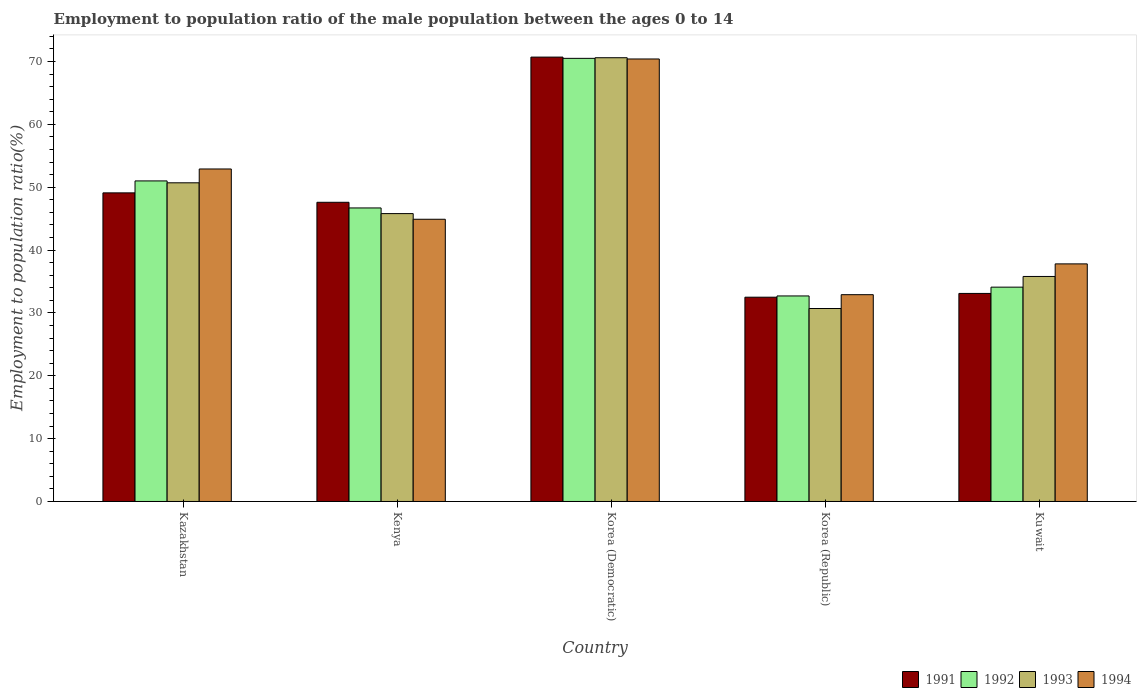Are the number of bars per tick equal to the number of legend labels?
Provide a succinct answer. Yes. How many bars are there on the 4th tick from the left?
Offer a terse response. 4. What is the label of the 5th group of bars from the left?
Provide a succinct answer. Kuwait. In how many cases, is the number of bars for a given country not equal to the number of legend labels?
Make the answer very short. 0. What is the employment to population ratio in 1992 in Kuwait?
Your answer should be compact. 34.1. Across all countries, what is the maximum employment to population ratio in 1994?
Offer a terse response. 70.4. Across all countries, what is the minimum employment to population ratio in 1994?
Your response must be concise. 32.9. In which country was the employment to population ratio in 1993 maximum?
Give a very brief answer. Korea (Democratic). In which country was the employment to population ratio in 1993 minimum?
Offer a very short reply. Korea (Republic). What is the total employment to population ratio in 1992 in the graph?
Your answer should be very brief. 235. What is the difference between the employment to population ratio in 1993 in Korea (Republic) and that in Kuwait?
Offer a very short reply. -5.1. What is the difference between the employment to population ratio in 1994 in Korea (Democratic) and the employment to population ratio in 1992 in Kenya?
Your answer should be very brief. 23.7. What is the average employment to population ratio in 1993 per country?
Keep it short and to the point. 46.72. What is the difference between the employment to population ratio of/in 1992 and employment to population ratio of/in 1993 in Kenya?
Give a very brief answer. 0.9. What is the ratio of the employment to population ratio in 1994 in Kenya to that in Korea (Republic)?
Your response must be concise. 1.36. What is the difference between the highest and the second highest employment to population ratio in 1994?
Offer a very short reply. -17.5. What is the difference between the highest and the lowest employment to population ratio in 1993?
Keep it short and to the point. 39.9. What does the 2nd bar from the left in Korea (Republic) represents?
Offer a very short reply. 1992. What does the 3rd bar from the right in Kenya represents?
Offer a terse response. 1992. Does the graph contain any zero values?
Offer a very short reply. No. How many legend labels are there?
Make the answer very short. 4. How are the legend labels stacked?
Ensure brevity in your answer.  Horizontal. What is the title of the graph?
Give a very brief answer. Employment to population ratio of the male population between the ages 0 to 14. Does "2003" appear as one of the legend labels in the graph?
Make the answer very short. No. What is the label or title of the X-axis?
Keep it short and to the point. Country. What is the label or title of the Y-axis?
Your answer should be compact. Employment to population ratio(%). What is the Employment to population ratio(%) in 1991 in Kazakhstan?
Keep it short and to the point. 49.1. What is the Employment to population ratio(%) in 1993 in Kazakhstan?
Make the answer very short. 50.7. What is the Employment to population ratio(%) in 1994 in Kazakhstan?
Your answer should be compact. 52.9. What is the Employment to population ratio(%) in 1991 in Kenya?
Your response must be concise. 47.6. What is the Employment to population ratio(%) of 1992 in Kenya?
Ensure brevity in your answer.  46.7. What is the Employment to population ratio(%) in 1993 in Kenya?
Keep it short and to the point. 45.8. What is the Employment to population ratio(%) in 1994 in Kenya?
Your answer should be very brief. 44.9. What is the Employment to population ratio(%) of 1991 in Korea (Democratic)?
Make the answer very short. 70.7. What is the Employment to population ratio(%) in 1992 in Korea (Democratic)?
Offer a terse response. 70.5. What is the Employment to population ratio(%) in 1993 in Korea (Democratic)?
Your response must be concise. 70.6. What is the Employment to population ratio(%) in 1994 in Korea (Democratic)?
Make the answer very short. 70.4. What is the Employment to population ratio(%) of 1991 in Korea (Republic)?
Your answer should be compact. 32.5. What is the Employment to population ratio(%) in 1992 in Korea (Republic)?
Your response must be concise. 32.7. What is the Employment to population ratio(%) in 1993 in Korea (Republic)?
Your answer should be very brief. 30.7. What is the Employment to population ratio(%) of 1994 in Korea (Republic)?
Your answer should be very brief. 32.9. What is the Employment to population ratio(%) in 1991 in Kuwait?
Make the answer very short. 33.1. What is the Employment to population ratio(%) of 1992 in Kuwait?
Your answer should be compact. 34.1. What is the Employment to population ratio(%) in 1993 in Kuwait?
Offer a terse response. 35.8. What is the Employment to population ratio(%) of 1994 in Kuwait?
Provide a short and direct response. 37.8. Across all countries, what is the maximum Employment to population ratio(%) of 1991?
Offer a very short reply. 70.7. Across all countries, what is the maximum Employment to population ratio(%) in 1992?
Keep it short and to the point. 70.5. Across all countries, what is the maximum Employment to population ratio(%) in 1993?
Ensure brevity in your answer.  70.6. Across all countries, what is the maximum Employment to population ratio(%) in 1994?
Provide a short and direct response. 70.4. Across all countries, what is the minimum Employment to population ratio(%) of 1991?
Your answer should be very brief. 32.5. Across all countries, what is the minimum Employment to population ratio(%) in 1992?
Your answer should be very brief. 32.7. Across all countries, what is the minimum Employment to population ratio(%) of 1993?
Your response must be concise. 30.7. Across all countries, what is the minimum Employment to population ratio(%) of 1994?
Offer a terse response. 32.9. What is the total Employment to population ratio(%) of 1991 in the graph?
Provide a short and direct response. 233. What is the total Employment to population ratio(%) of 1992 in the graph?
Provide a short and direct response. 235. What is the total Employment to population ratio(%) in 1993 in the graph?
Offer a very short reply. 233.6. What is the total Employment to population ratio(%) of 1994 in the graph?
Your answer should be very brief. 238.9. What is the difference between the Employment to population ratio(%) in 1991 in Kazakhstan and that in Korea (Democratic)?
Provide a succinct answer. -21.6. What is the difference between the Employment to population ratio(%) of 1992 in Kazakhstan and that in Korea (Democratic)?
Your answer should be compact. -19.5. What is the difference between the Employment to population ratio(%) of 1993 in Kazakhstan and that in Korea (Democratic)?
Offer a terse response. -19.9. What is the difference between the Employment to population ratio(%) in 1994 in Kazakhstan and that in Korea (Democratic)?
Provide a short and direct response. -17.5. What is the difference between the Employment to population ratio(%) in 1991 in Kazakhstan and that in Korea (Republic)?
Keep it short and to the point. 16.6. What is the difference between the Employment to population ratio(%) in 1991 in Kazakhstan and that in Kuwait?
Provide a short and direct response. 16. What is the difference between the Employment to population ratio(%) of 1991 in Kenya and that in Korea (Democratic)?
Offer a very short reply. -23.1. What is the difference between the Employment to population ratio(%) in 1992 in Kenya and that in Korea (Democratic)?
Give a very brief answer. -23.8. What is the difference between the Employment to population ratio(%) in 1993 in Kenya and that in Korea (Democratic)?
Provide a short and direct response. -24.8. What is the difference between the Employment to population ratio(%) of 1994 in Kenya and that in Korea (Democratic)?
Ensure brevity in your answer.  -25.5. What is the difference between the Employment to population ratio(%) in 1991 in Kenya and that in Korea (Republic)?
Give a very brief answer. 15.1. What is the difference between the Employment to population ratio(%) of 1991 in Kenya and that in Kuwait?
Make the answer very short. 14.5. What is the difference between the Employment to population ratio(%) of 1993 in Kenya and that in Kuwait?
Keep it short and to the point. 10. What is the difference between the Employment to population ratio(%) in 1994 in Kenya and that in Kuwait?
Your response must be concise. 7.1. What is the difference between the Employment to population ratio(%) of 1991 in Korea (Democratic) and that in Korea (Republic)?
Make the answer very short. 38.2. What is the difference between the Employment to population ratio(%) in 1992 in Korea (Democratic) and that in Korea (Republic)?
Offer a terse response. 37.8. What is the difference between the Employment to population ratio(%) of 1993 in Korea (Democratic) and that in Korea (Republic)?
Your answer should be compact. 39.9. What is the difference between the Employment to population ratio(%) of 1994 in Korea (Democratic) and that in Korea (Republic)?
Ensure brevity in your answer.  37.5. What is the difference between the Employment to population ratio(%) of 1991 in Korea (Democratic) and that in Kuwait?
Give a very brief answer. 37.6. What is the difference between the Employment to population ratio(%) in 1992 in Korea (Democratic) and that in Kuwait?
Provide a short and direct response. 36.4. What is the difference between the Employment to population ratio(%) in 1993 in Korea (Democratic) and that in Kuwait?
Provide a short and direct response. 34.8. What is the difference between the Employment to population ratio(%) of 1994 in Korea (Democratic) and that in Kuwait?
Your answer should be compact. 32.6. What is the difference between the Employment to population ratio(%) in 1991 in Korea (Republic) and that in Kuwait?
Ensure brevity in your answer.  -0.6. What is the difference between the Employment to population ratio(%) in 1992 in Korea (Republic) and that in Kuwait?
Offer a very short reply. -1.4. What is the difference between the Employment to population ratio(%) in 1993 in Korea (Republic) and that in Kuwait?
Offer a very short reply. -5.1. What is the difference between the Employment to population ratio(%) of 1994 in Korea (Republic) and that in Kuwait?
Offer a very short reply. -4.9. What is the difference between the Employment to population ratio(%) in 1992 in Kazakhstan and the Employment to population ratio(%) in 1994 in Kenya?
Your answer should be compact. 6.1. What is the difference between the Employment to population ratio(%) in 1991 in Kazakhstan and the Employment to population ratio(%) in 1992 in Korea (Democratic)?
Give a very brief answer. -21.4. What is the difference between the Employment to population ratio(%) in 1991 in Kazakhstan and the Employment to population ratio(%) in 1993 in Korea (Democratic)?
Keep it short and to the point. -21.5. What is the difference between the Employment to population ratio(%) in 1991 in Kazakhstan and the Employment to population ratio(%) in 1994 in Korea (Democratic)?
Give a very brief answer. -21.3. What is the difference between the Employment to population ratio(%) of 1992 in Kazakhstan and the Employment to population ratio(%) of 1993 in Korea (Democratic)?
Make the answer very short. -19.6. What is the difference between the Employment to population ratio(%) in 1992 in Kazakhstan and the Employment to population ratio(%) in 1994 in Korea (Democratic)?
Provide a succinct answer. -19.4. What is the difference between the Employment to population ratio(%) of 1993 in Kazakhstan and the Employment to population ratio(%) of 1994 in Korea (Democratic)?
Offer a very short reply. -19.7. What is the difference between the Employment to population ratio(%) of 1991 in Kazakhstan and the Employment to population ratio(%) of 1993 in Korea (Republic)?
Give a very brief answer. 18.4. What is the difference between the Employment to population ratio(%) of 1992 in Kazakhstan and the Employment to population ratio(%) of 1993 in Korea (Republic)?
Offer a very short reply. 20.3. What is the difference between the Employment to population ratio(%) of 1992 in Kazakhstan and the Employment to population ratio(%) of 1993 in Kuwait?
Make the answer very short. 15.2. What is the difference between the Employment to population ratio(%) in 1993 in Kazakhstan and the Employment to population ratio(%) in 1994 in Kuwait?
Ensure brevity in your answer.  12.9. What is the difference between the Employment to population ratio(%) of 1991 in Kenya and the Employment to population ratio(%) of 1992 in Korea (Democratic)?
Offer a terse response. -22.9. What is the difference between the Employment to population ratio(%) in 1991 in Kenya and the Employment to population ratio(%) in 1994 in Korea (Democratic)?
Provide a short and direct response. -22.8. What is the difference between the Employment to population ratio(%) of 1992 in Kenya and the Employment to population ratio(%) of 1993 in Korea (Democratic)?
Provide a short and direct response. -23.9. What is the difference between the Employment to population ratio(%) of 1992 in Kenya and the Employment to population ratio(%) of 1994 in Korea (Democratic)?
Provide a succinct answer. -23.7. What is the difference between the Employment to population ratio(%) of 1993 in Kenya and the Employment to population ratio(%) of 1994 in Korea (Democratic)?
Offer a very short reply. -24.6. What is the difference between the Employment to population ratio(%) in 1991 in Kenya and the Employment to population ratio(%) in 1992 in Korea (Republic)?
Offer a very short reply. 14.9. What is the difference between the Employment to population ratio(%) of 1991 in Kenya and the Employment to population ratio(%) of 1993 in Korea (Republic)?
Your answer should be compact. 16.9. What is the difference between the Employment to population ratio(%) of 1991 in Kenya and the Employment to population ratio(%) of 1994 in Korea (Republic)?
Your answer should be compact. 14.7. What is the difference between the Employment to population ratio(%) of 1992 in Kenya and the Employment to population ratio(%) of 1993 in Korea (Republic)?
Make the answer very short. 16. What is the difference between the Employment to population ratio(%) in 1993 in Kenya and the Employment to population ratio(%) in 1994 in Korea (Republic)?
Offer a very short reply. 12.9. What is the difference between the Employment to population ratio(%) of 1991 in Kenya and the Employment to population ratio(%) of 1994 in Kuwait?
Ensure brevity in your answer.  9.8. What is the difference between the Employment to population ratio(%) of 1992 in Kenya and the Employment to population ratio(%) of 1993 in Kuwait?
Offer a terse response. 10.9. What is the difference between the Employment to population ratio(%) of 1992 in Kenya and the Employment to population ratio(%) of 1994 in Kuwait?
Give a very brief answer. 8.9. What is the difference between the Employment to population ratio(%) in 1993 in Kenya and the Employment to population ratio(%) in 1994 in Kuwait?
Your answer should be very brief. 8. What is the difference between the Employment to population ratio(%) in 1991 in Korea (Democratic) and the Employment to population ratio(%) in 1992 in Korea (Republic)?
Make the answer very short. 38. What is the difference between the Employment to population ratio(%) of 1991 in Korea (Democratic) and the Employment to population ratio(%) of 1994 in Korea (Republic)?
Provide a succinct answer. 37.8. What is the difference between the Employment to population ratio(%) of 1992 in Korea (Democratic) and the Employment to population ratio(%) of 1993 in Korea (Republic)?
Provide a short and direct response. 39.8. What is the difference between the Employment to population ratio(%) of 1992 in Korea (Democratic) and the Employment to population ratio(%) of 1994 in Korea (Republic)?
Provide a short and direct response. 37.6. What is the difference between the Employment to population ratio(%) of 1993 in Korea (Democratic) and the Employment to population ratio(%) of 1994 in Korea (Republic)?
Your answer should be compact. 37.7. What is the difference between the Employment to population ratio(%) in 1991 in Korea (Democratic) and the Employment to population ratio(%) in 1992 in Kuwait?
Provide a short and direct response. 36.6. What is the difference between the Employment to population ratio(%) of 1991 in Korea (Democratic) and the Employment to population ratio(%) of 1993 in Kuwait?
Your answer should be compact. 34.9. What is the difference between the Employment to population ratio(%) in 1991 in Korea (Democratic) and the Employment to population ratio(%) in 1994 in Kuwait?
Ensure brevity in your answer.  32.9. What is the difference between the Employment to population ratio(%) in 1992 in Korea (Democratic) and the Employment to population ratio(%) in 1993 in Kuwait?
Offer a terse response. 34.7. What is the difference between the Employment to population ratio(%) in 1992 in Korea (Democratic) and the Employment to population ratio(%) in 1994 in Kuwait?
Your answer should be very brief. 32.7. What is the difference between the Employment to population ratio(%) of 1993 in Korea (Democratic) and the Employment to population ratio(%) of 1994 in Kuwait?
Make the answer very short. 32.8. What is the difference between the Employment to population ratio(%) of 1991 in Korea (Republic) and the Employment to population ratio(%) of 1994 in Kuwait?
Your answer should be very brief. -5.3. What is the difference between the Employment to population ratio(%) of 1992 in Korea (Republic) and the Employment to population ratio(%) of 1993 in Kuwait?
Your response must be concise. -3.1. What is the difference between the Employment to population ratio(%) of 1993 in Korea (Republic) and the Employment to population ratio(%) of 1994 in Kuwait?
Provide a short and direct response. -7.1. What is the average Employment to population ratio(%) of 1991 per country?
Offer a terse response. 46.6. What is the average Employment to population ratio(%) of 1992 per country?
Provide a succinct answer. 47. What is the average Employment to population ratio(%) of 1993 per country?
Provide a short and direct response. 46.72. What is the average Employment to population ratio(%) of 1994 per country?
Ensure brevity in your answer.  47.78. What is the difference between the Employment to population ratio(%) of 1991 and Employment to population ratio(%) of 1992 in Kazakhstan?
Keep it short and to the point. -1.9. What is the difference between the Employment to population ratio(%) in 1991 and Employment to population ratio(%) in 1993 in Kazakhstan?
Offer a very short reply. -1.6. What is the difference between the Employment to population ratio(%) in 1993 and Employment to population ratio(%) in 1994 in Kazakhstan?
Provide a succinct answer. -2.2. What is the difference between the Employment to population ratio(%) in 1991 and Employment to population ratio(%) in 1992 in Kenya?
Give a very brief answer. 0.9. What is the difference between the Employment to population ratio(%) of 1991 and Employment to population ratio(%) of 1994 in Kenya?
Offer a very short reply. 2.7. What is the difference between the Employment to population ratio(%) of 1992 and Employment to population ratio(%) of 1993 in Kenya?
Offer a very short reply. 0.9. What is the difference between the Employment to population ratio(%) of 1992 and Employment to population ratio(%) of 1994 in Kenya?
Offer a very short reply. 1.8. What is the difference between the Employment to population ratio(%) of 1993 and Employment to population ratio(%) of 1994 in Kenya?
Your answer should be compact. 0.9. What is the difference between the Employment to population ratio(%) of 1991 and Employment to population ratio(%) of 1993 in Korea (Democratic)?
Your response must be concise. 0.1. What is the difference between the Employment to population ratio(%) in 1991 and Employment to population ratio(%) in 1994 in Korea (Democratic)?
Offer a terse response. 0.3. What is the difference between the Employment to population ratio(%) in 1992 and Employment to population ratio(%) in 1993 in Korea (Democratic)?
Your response must be concise. -0.1. What is the difference between the Employment to population ratio(%) of 1992 and Employment to population ratio(%) of 1994 in Korea (Democratic)?
Your response must be concise. 0.1. What is the difference between the Employment to population ratio(%) in 1993 and Employment to population ratio(%) in 1994 in Korea (Democratic)?
Provide a short and direct response. 0.2. What is the difference between the Employment to population ratio(%) of 1991 and Employment to population ratio(%) of 1992 in Korea (Republic)?
Provide a short and direct response. -0.2. What is the difference between the Employment to population ratio(%) of 1991 and Employment to population ratio(%) of 1993 in Korea (Republic)?
Your answer should be compact. 1.8. What is the difference between the Employment to population ratio(%) of 1993 and Employment to population ratio(%) of 1994 in Korea (Republic)?
Offer a very short reply. -2.2. What is the difference between the Employment to population ratio(%) in 1991 and Employment to population ratio(%) in 1992 in Kuwait?
Your response must be concise. -1. What is the difference between the Employment to population ratio(%) of 1992 and Employment to population ratio(%) of 1993 in Kuwait?
Offer a terse response. -1.7. What is the ratio of the Employment to population ratio(%) in 1991 in Kazakhstan to that in Kenya?
Provide a short and direct response. 1.03. What is the ratio of the Employment to population ratio(%) of 1992 in Kazakhstan to that in Kenya?
Provide a succinct answer. 1.09. What is the ratio of the Employment to population ratio(%) in 1993 in Kazakhstan to that in Kenya?
Offer a very short reply. 1.11. What is the ratio of the Employment to population ratio(%) of 1994 in Kazakhstan to that in Kenya?
Offer a terse response. 1.18. What is the ratio of the Employment to population ratio(%) of 1991 in Kazakhstan to that in Korea (Democratic)?
Make the answer very short. 0.69. What is the ratio of the Employment to population ratio(%) of 1992 in Kazakhstan to that in Korea (Democratic)?
Ensure brevity in your answer.  0.72. What is the ratio of the Employment to population ratio(%) in 1993 in Kazakhstan to that in Korea (Democratic)?
Offer a very short reply. 0.72. What is the ratio of the Employment to population ratio(%) in 1994 in Kazakhstan to that in Korea (Democratic)?
Keep it short and to the point. 0.75. What is the ratio of the Employment to population ratio(%) in 1991 in Kazakhstan to that in Korea (Republic)?
Your response must be concise. 1.51. What is the ratio of the Employment to population ratio(%) of 1992 in Kazakhstan to that in Korea (Republic)?
Your answer should be very brief. 1.56. What is the ratio of the Employment to population ratio(%) in 1993 in Kazakhstan to that in Korea (Republic)?
Offer a very short reply. 1.65. What is the ratio of the Employment to population ratio(%) in 1994 in Kazakhstan to that in Korea (Republic)?
Your answer should be compact. 1.61. What is the ratio of the Employment to population ratio(%) of 1991 in Kazakhstan to that in Kuwait?
Offer a very short reply. 1.48. What is the ratio of the Employment to population ratio(%) of 1992 in Kazakhstan to that in Kuwait?
Your answer should be compact. 1.5. What is the ratio of the Employment to population ratio(%) in 1993 in Kazakhstan to that in Kuwait?
Give a very brief answer. 1.42. What is the ratio of the Employment to population ratio(%) in 1994 in Kazakhstan to that in Kuwait?
Keep it short and to the point. 1.4. What is the ratio of the Employment to population ratio(%) of 1991 in Kenya to that in Korea (Democratic)?
Offer a terse response. 0.67. What is the ratio of the Employment to population ratio(%) in 1992 in Kenya to that in Korea (Democratic)?
Your answer should be compact. 0.66. What is the ratio of the Employment to population ratio(%) in 1993 in Kenya to that in Korea (Democratic)?
Your answer should be compact. 0.65. What is the ratio of the Employment to population ratio(%) of 1994 in Kenya to that in Korea (Democratic)?
Your answer should be compact. 0.64. What is the ratio of the Employment to population ratio(%) of 1991 in Kenya to that in Korea (Republic)?
Your response must be concise. 1.46. What is the ratio of the Employment to population ratio(%) in 1992 in Kenya to that in Korea (Republic)?
Your answer should be very brief. 1.43. What is the ratio of the Employment to population ratio(%) of 1993 in Kenya to that in Korea (Republic)?
Give a very brief answer. 1.49. What is the ratio of the Employment to population ratio(%) of 1994 in Kenya to that in Korea (Republic)?
Keep it short and to the point. 1.36. What is the ratio of the Employment to population ratio(%) in 1991 in Kenya to that in Kuwait?
Make the answer very short. 1.44. What is the ratio of the Employment to population ratio(%) in 1992 in Kenya to that in Kuwait?
Your answer should be very brief. 1.37. What is the ratio of the Employment to population ratio(%) of 1993 in Kenya to that in Kuwait?
Ensure brevity in your answer.  1.28. What is the ratio of the Employment to population ratio(%) in 1994 in Kenya to that in Kuwait?
Your response must be concise. 1.19. What is the ratio of the Employment to population ratio(%) in 1991 in Korea (Democratic) to that in Korea (Republic)?
Your answer should be very brief. 2.18. What is the ratio of the Employment to population ratio(%) in 1992 in Korea (Democratic) to that in Korea (Republic)?
Make the answer very short. 2.16. What is the ratio of the Employment to population ratio(%) in 1993 in Korea (Democratic) to that in Korea (Republic)?
Provide a succinct answer. 2.3. What is the ratio of the Employment to population ratio(%) in 1994 in Korea (Democratic) to that in Korea (Republic)?
Your answer should be compact. 2.14. What is the ratio of the Employment to population ratio(%) of 1991 in Korea (Democratic) to that in Kuwait?
Provide a succinct answer. 2.14. What is the ratio of the Employment to population ratio(%) in 1992 in Korea (Democratic) to that in Kuwait?
Keep it short and to the point. 2.07. What is the ratio of the Employment to population ratio(%) in 1993 in Korea (Democratic) to that in Kuwait?
Your response must be concise. 1.97. What is the ratio of the Employment to population ratio(%) in 1994 in Korea (Democratic) to that in Kuwait?
Offer a very short reply. 1.86. What is the ratio of the Employment to population ratio(%) in 1991 in Korea (Republic) to that in Kuwait?
Offer a terse response. 0.98. What is the ratio of the Employment to population ratio(%) in 1992 in Korea (Republic) to that in Kuwait?
Make the answer very short. 0.96. What is the ratio of the Employment to population ratio(%) in 1993 in Korea (Republic) to that in Kuwait?
Your response must be concise. 0.86. What is the ratio of the Employment to population ratio(%) of 1994 in Korea (Republic) to that in Kuwait?
Ensure brevity in your answer.  0.87. What is the difference between the highest and the second highest Employment to population ratio(%) in 1991?
Make the answer very short. 21.6. What is the difference between the highest and the second highest Employment to population ratio(%) in 1992?
Provide a short and direct response. 19.5. What is the difference between the highest and the second highest Employment to population ratio(%) in 1993?
Provide a short and direct response. 19.9. What is the difference between the highest and the lowest Employment to population ratio(%) in 1991?
Give a very brief answer. 38.2. What is the difference between the highest and the lowest Employment to population ratio(%) in 1992?
Your answer should be compact. 37.8. What is the difference between the highest and the lowest Employment to population ratio(%) in 1993?
Your answer should be compact. 39.9. What is the difference between the highest and the lowest Employment to population ratio(%) of 1994?
Provide a short and direct response. 37.5. 